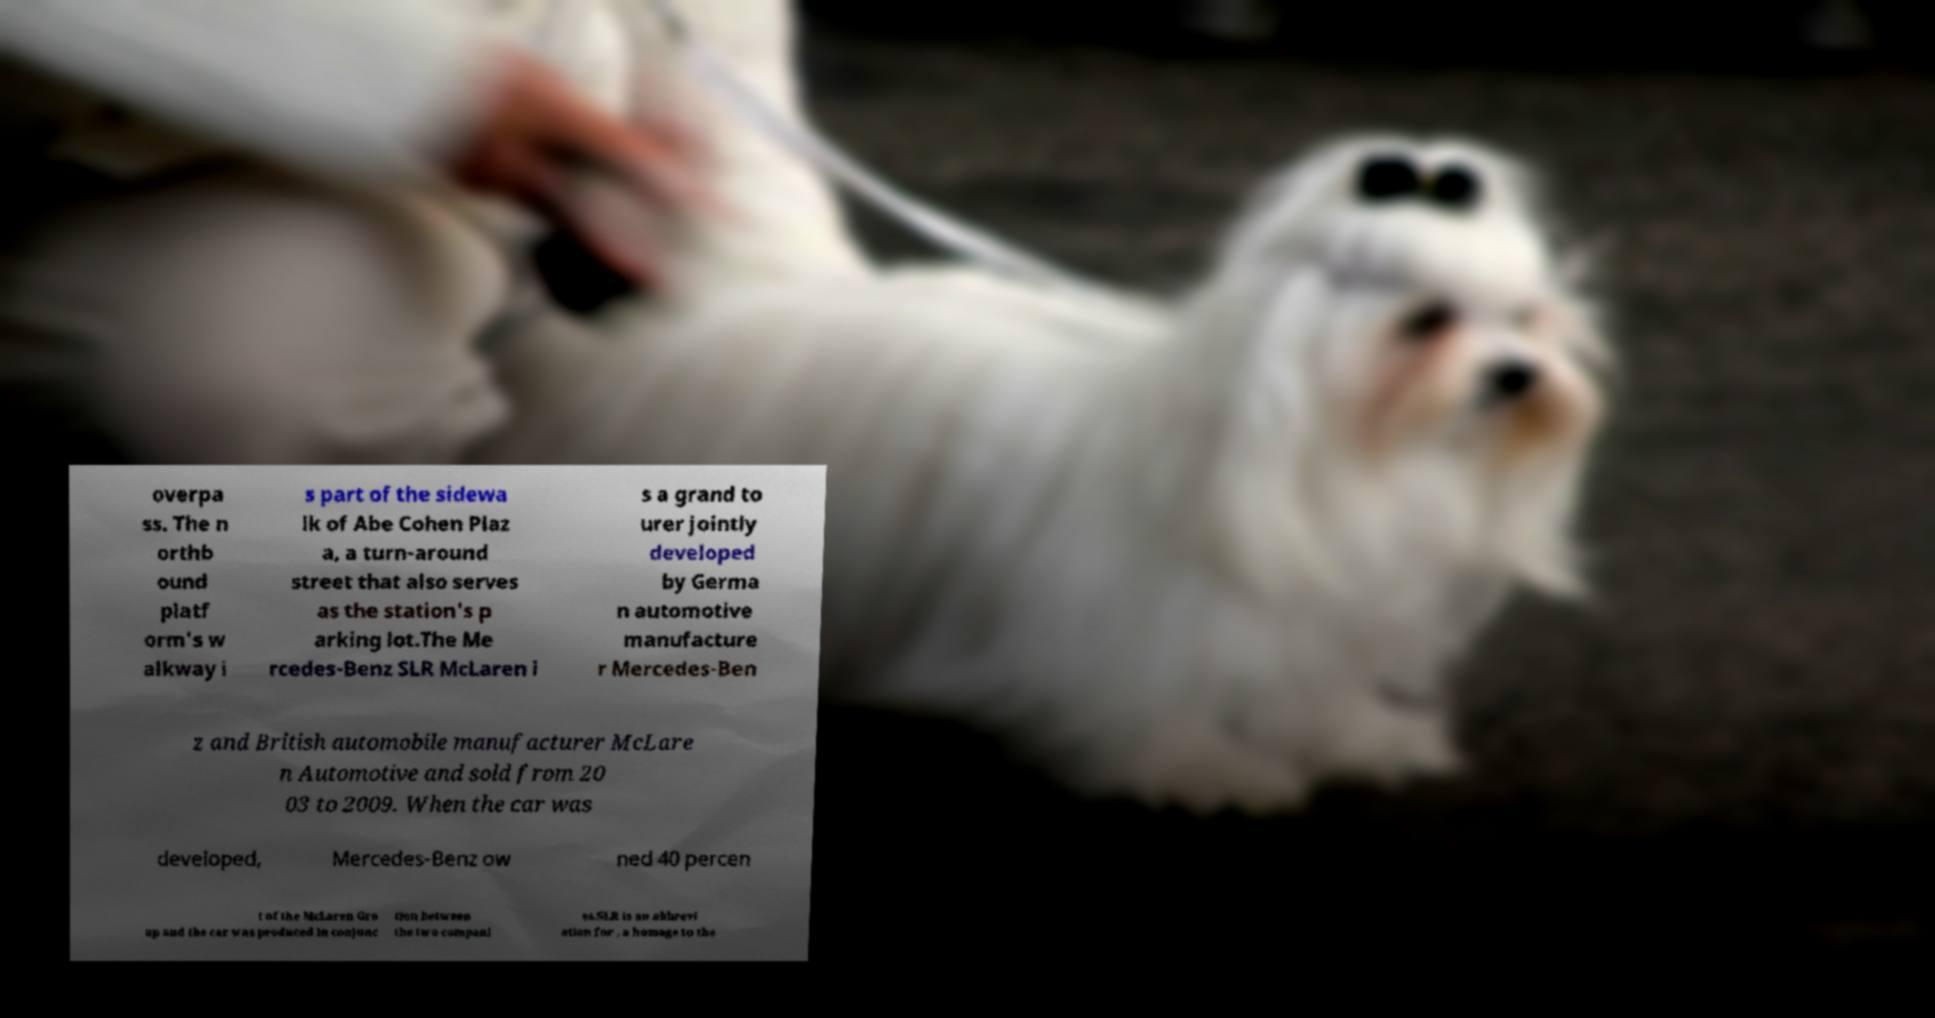I need the written content from this picture converted into text. Can you do that? overpa ss. The n orthb ound platf orm's w alkway i s part of the sidewa lk of Abe Cohen Plaz a, a turn-around street that also serves as the station's p arking lot.The Me rcedes-Benz SLR McLaren i s a grand to urer jointly developed by Germa n automotive manufacture r Mercedes-Ben z and British automobile manufacturer McLare n Automotive and sold from 20 03 to 2009. When the car was developed, Mercedes-Benz ow ned 40 percen t of the McLaren Gro up and the car was produced in conjunc tion between the two compani es.SLR is an abbrevi ation for , a homage to the 